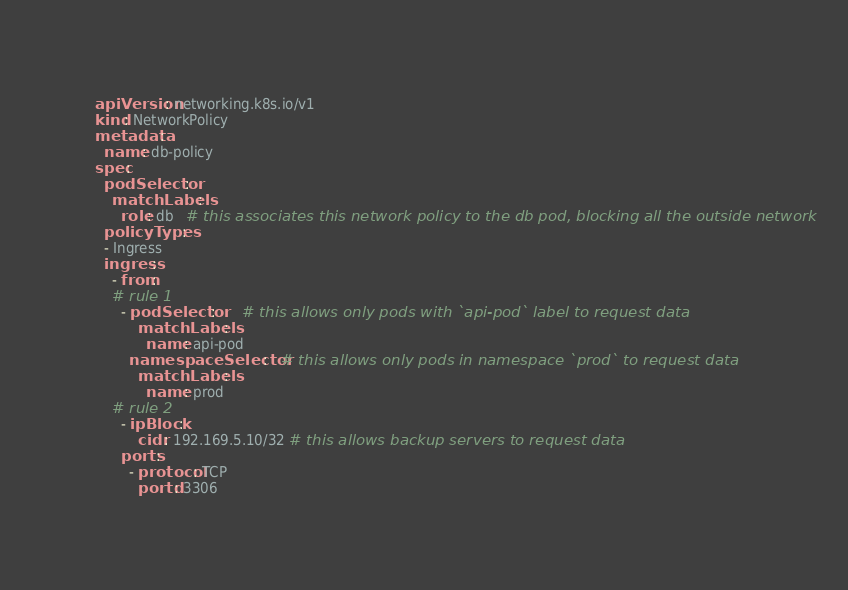Convert code to text. <code><loc_0><loc_0><loc_500><loc_500><_YAML_>apiVersion: networking.k8s.io/v1
kind: NetworkPolicy
metadata:
  name: db-policy
spec:
  podSelector:
    matchLabels:
      role: db   # this associates this network policy to the db pod, blocking all the outside network
  policyTypes:
  - Ingress
  ingress:
    - from:
    # rule 1
      - podSelector:      # this allows only pods with `api-pod` label to request data
          matchLabels:
            name: api-pod
        namespaceSelector:   # this allows only pods in namespace `prod` to request data
          matchLabels:
            name: prod
    # rule 2
      - ipBlock:
          cidr: 192.169.5.10/32 # this allows backup servers to request data
      ports:
        - protocol: TCP
          portd: 3306

</code> 